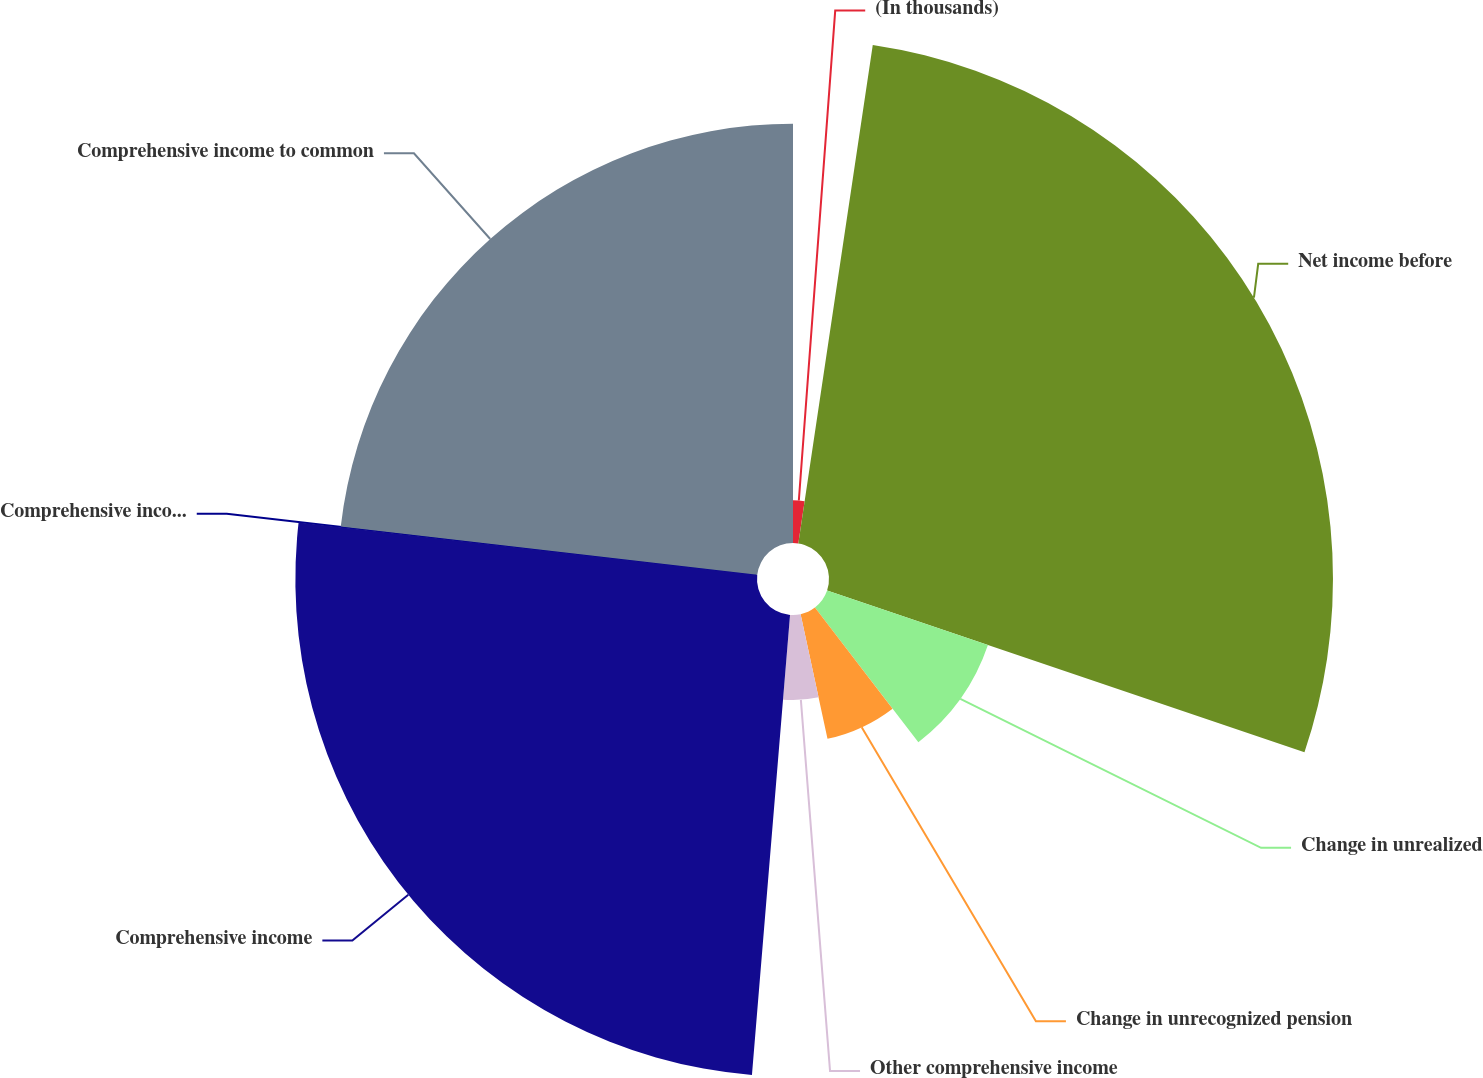Convert chart to OTSL. <chart><loc_0><loc_0><loc_500><loc_500><pie_chart><fcel>(In thousands)<fcel>Net income before<fcel>Change in unrealized<fcel>Change in unrecognized pension<fcel>Other comprehensive income<fcel>Comprehensive income<fcel>Comprehensive income to the<fcel>Comprehensive income to common<nl><fcel>2.36%<fcel>27.84%<fcel>9.38%<fcel>7.04%<fcel>4.7%<fcel>25.5%<fcel>0.03%<fcel>23.16%<nl></chart> 